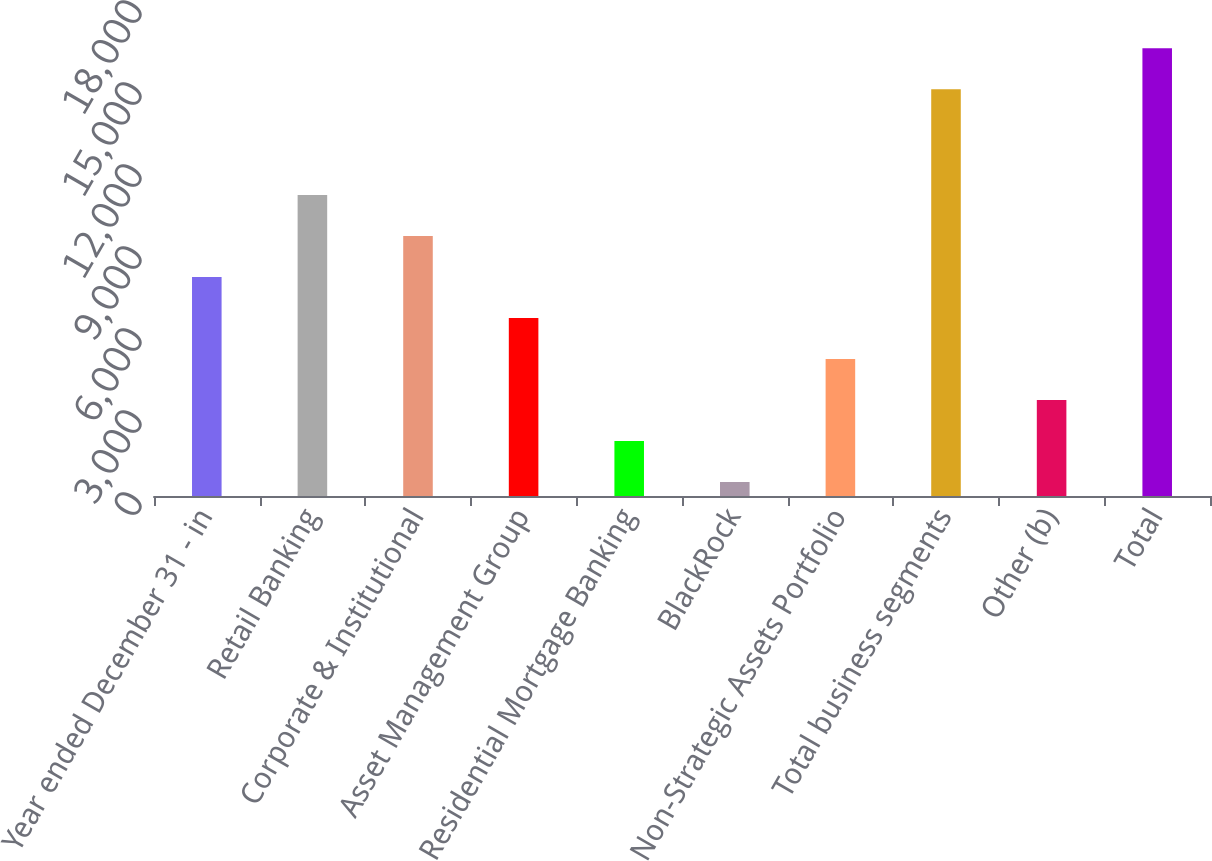<chart> <loc_0><loc_0><loc_500><loc_500><bar_chart><fcel>Year ended December 31 - in<fcel>Retail Banking<fcel>Corporate & Institutional<fcel>Asset Management Group<fcel>Residential Mortgage Banking<fcel>BlackRock<fcel>Non-Strategic Assets Portfolio<fcel>Total business segments<fcel>Other (b)<fcel>Total<nl><fcel>8012<fcel>11012<fcel>9512<fcel>6512<fcel>2012<fcel>512<fcel>5012<fcel>14879<fcel>3512<fcel>16379<nl></chart> 